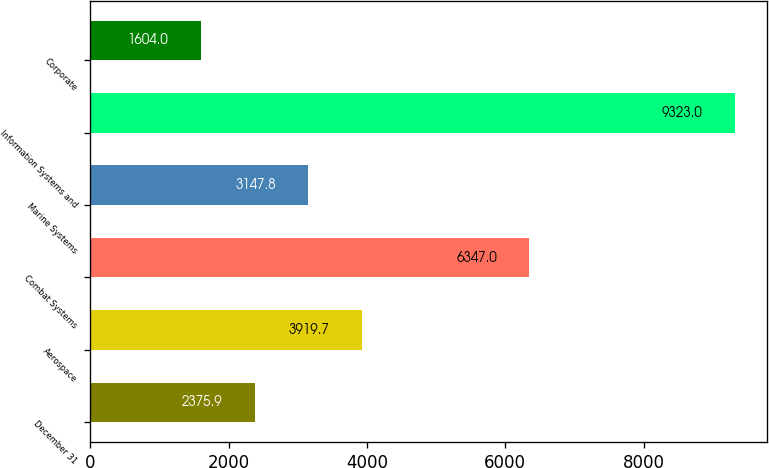<chart> <loc_0><loc_0><loc_500><loc_500><bar_chart><fcel>December 31<fcel>Aerospace<fcel>Combat Systems<fcel>Marine Systems<fcel>Information Systems and<fcel>Corporate<nl><fcel>2375.9<fcel>3919.7<fcel>6347<fcel>3147.8<fcel>9323<fcel>1604<nl></chart> 